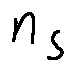Convert formula to latex. <formula><loc_0><loc_0><loc_500><loc_500>n _ { S }</formula> 